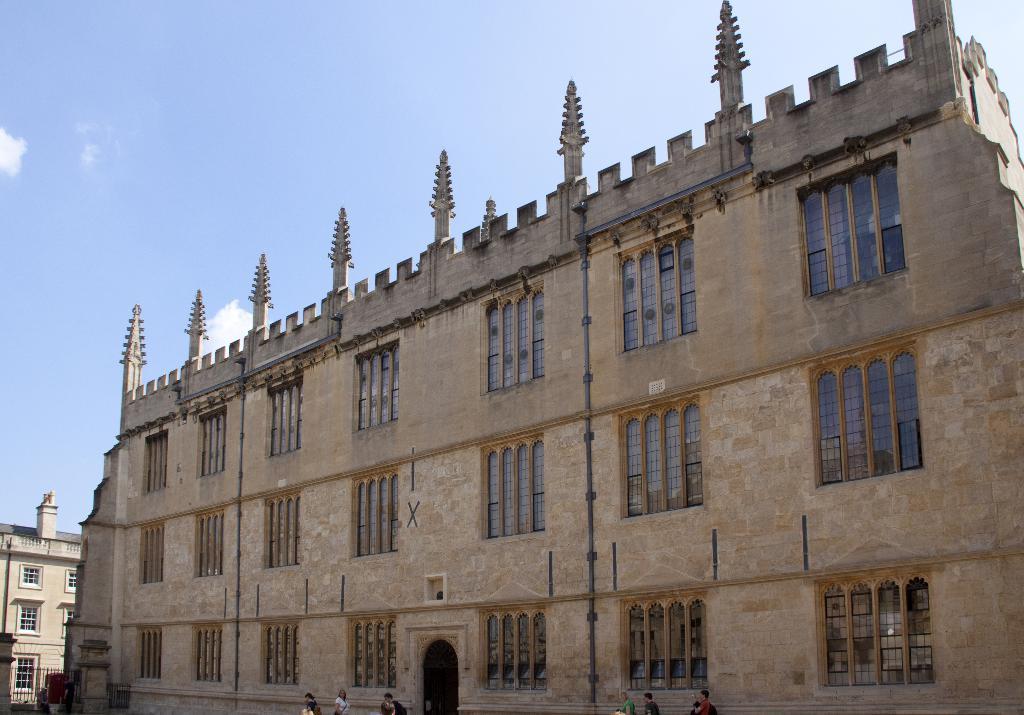What type of structure is present in the image? There is a building in the image. What features can be observed on the building? The building has windows and an entrance. What is happening in the background of the image? People are walking in the background of the image. What can be seen in the sky in the image? The sky is visible in the background of the image. What note is the cat playing on the piano in the image? There is no cat or piano present in the image. What advice does the parent give to the child in the image? There is no parent or child present in the image. 